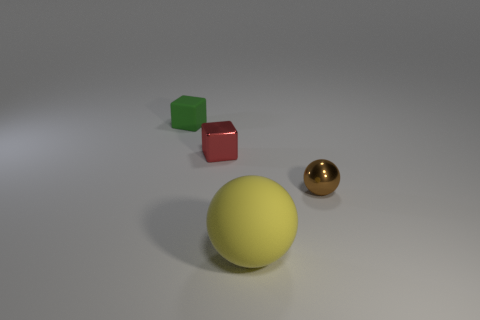What number of other objects are there of the same color as the big thing?
Your answer should be very brief. 0. What material is the thing in front of the shiny thing to the right of the matte object in front of the tiny matte cube made of?
Ensure brevity in your answer.  Rubber. How many cubes are big matte things or tiny objects?
Your answer should be very brief. 2. Is there anything else that has the same size as the yellow ball?
Provide a short and direct response. No. There is a tiny thing that is on the left side of the red metallic object on the right side of the tiny matte object; how many matte spheres are left of it?
Your answer should be very brief. 0. Is the yellow matte thing the same shape as the brown thing?
Give a very brief answer. Yes. Are the small cube that is to the right of the matte block and the small thing in front of the small red metallic cube made of the same material?
Provide a short and direct response. Yes. How many objects are either metallic things that are on the left side of the big sphere or tiny cubes right of the tiny green object?
Provide a short and direct response. 1. How many matte things are there?
Keep it short and to the point. 2. Is there another shiny thing of the same size as the red shiny thing?
Your answer should be very brief. Yes. 